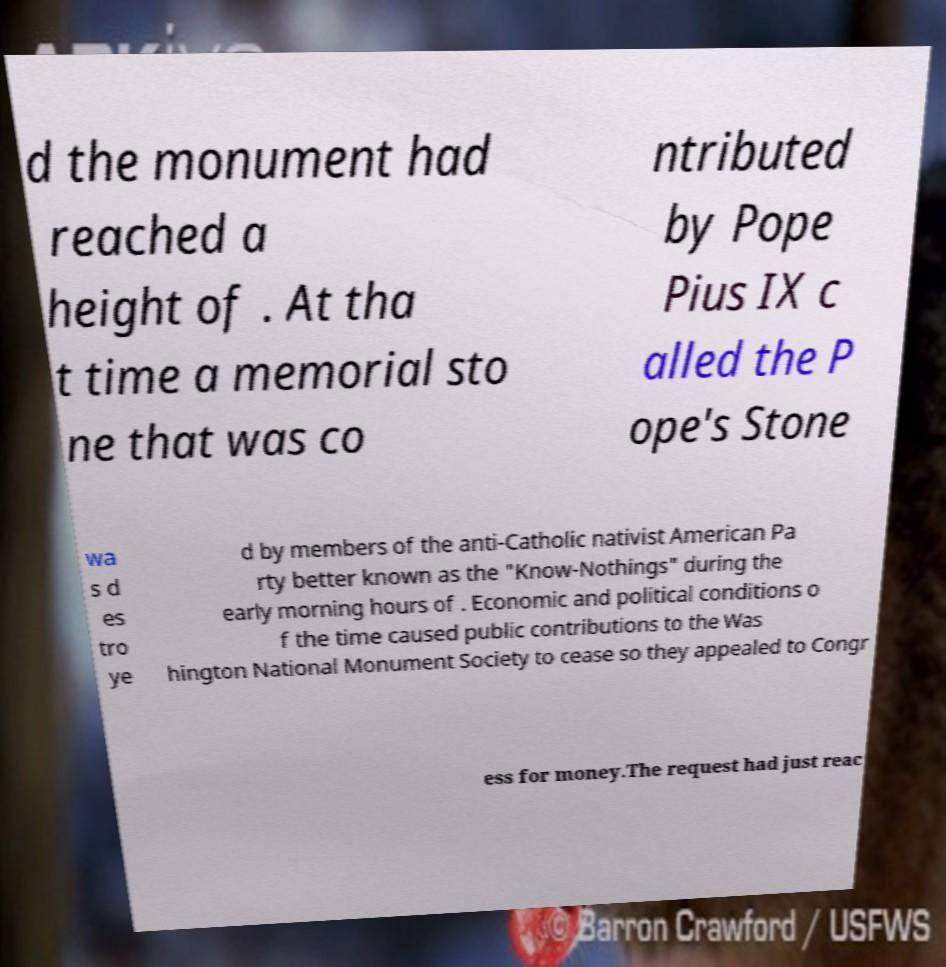Please read and relay the text visible in this image. What does it say? d the monument had reached a height of . At tha t time a memorial sto ne that was co ntributed by Pope Pius IX c alled the P ope's Stone wa s d es tro ye d by members of the anti-Catholic nativist American Pa rty better known as the "Know-Nothings" during the early morning hours of . Economic and political conditions o f the time caused public contributions to the Was hington National Monument Society to cease so they appealed to Congr ess for money.The request had just reac 